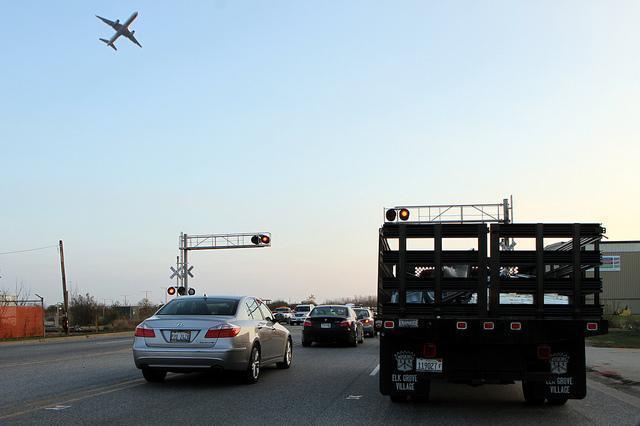How many cars are there?
Give a very brief answer. 2. 